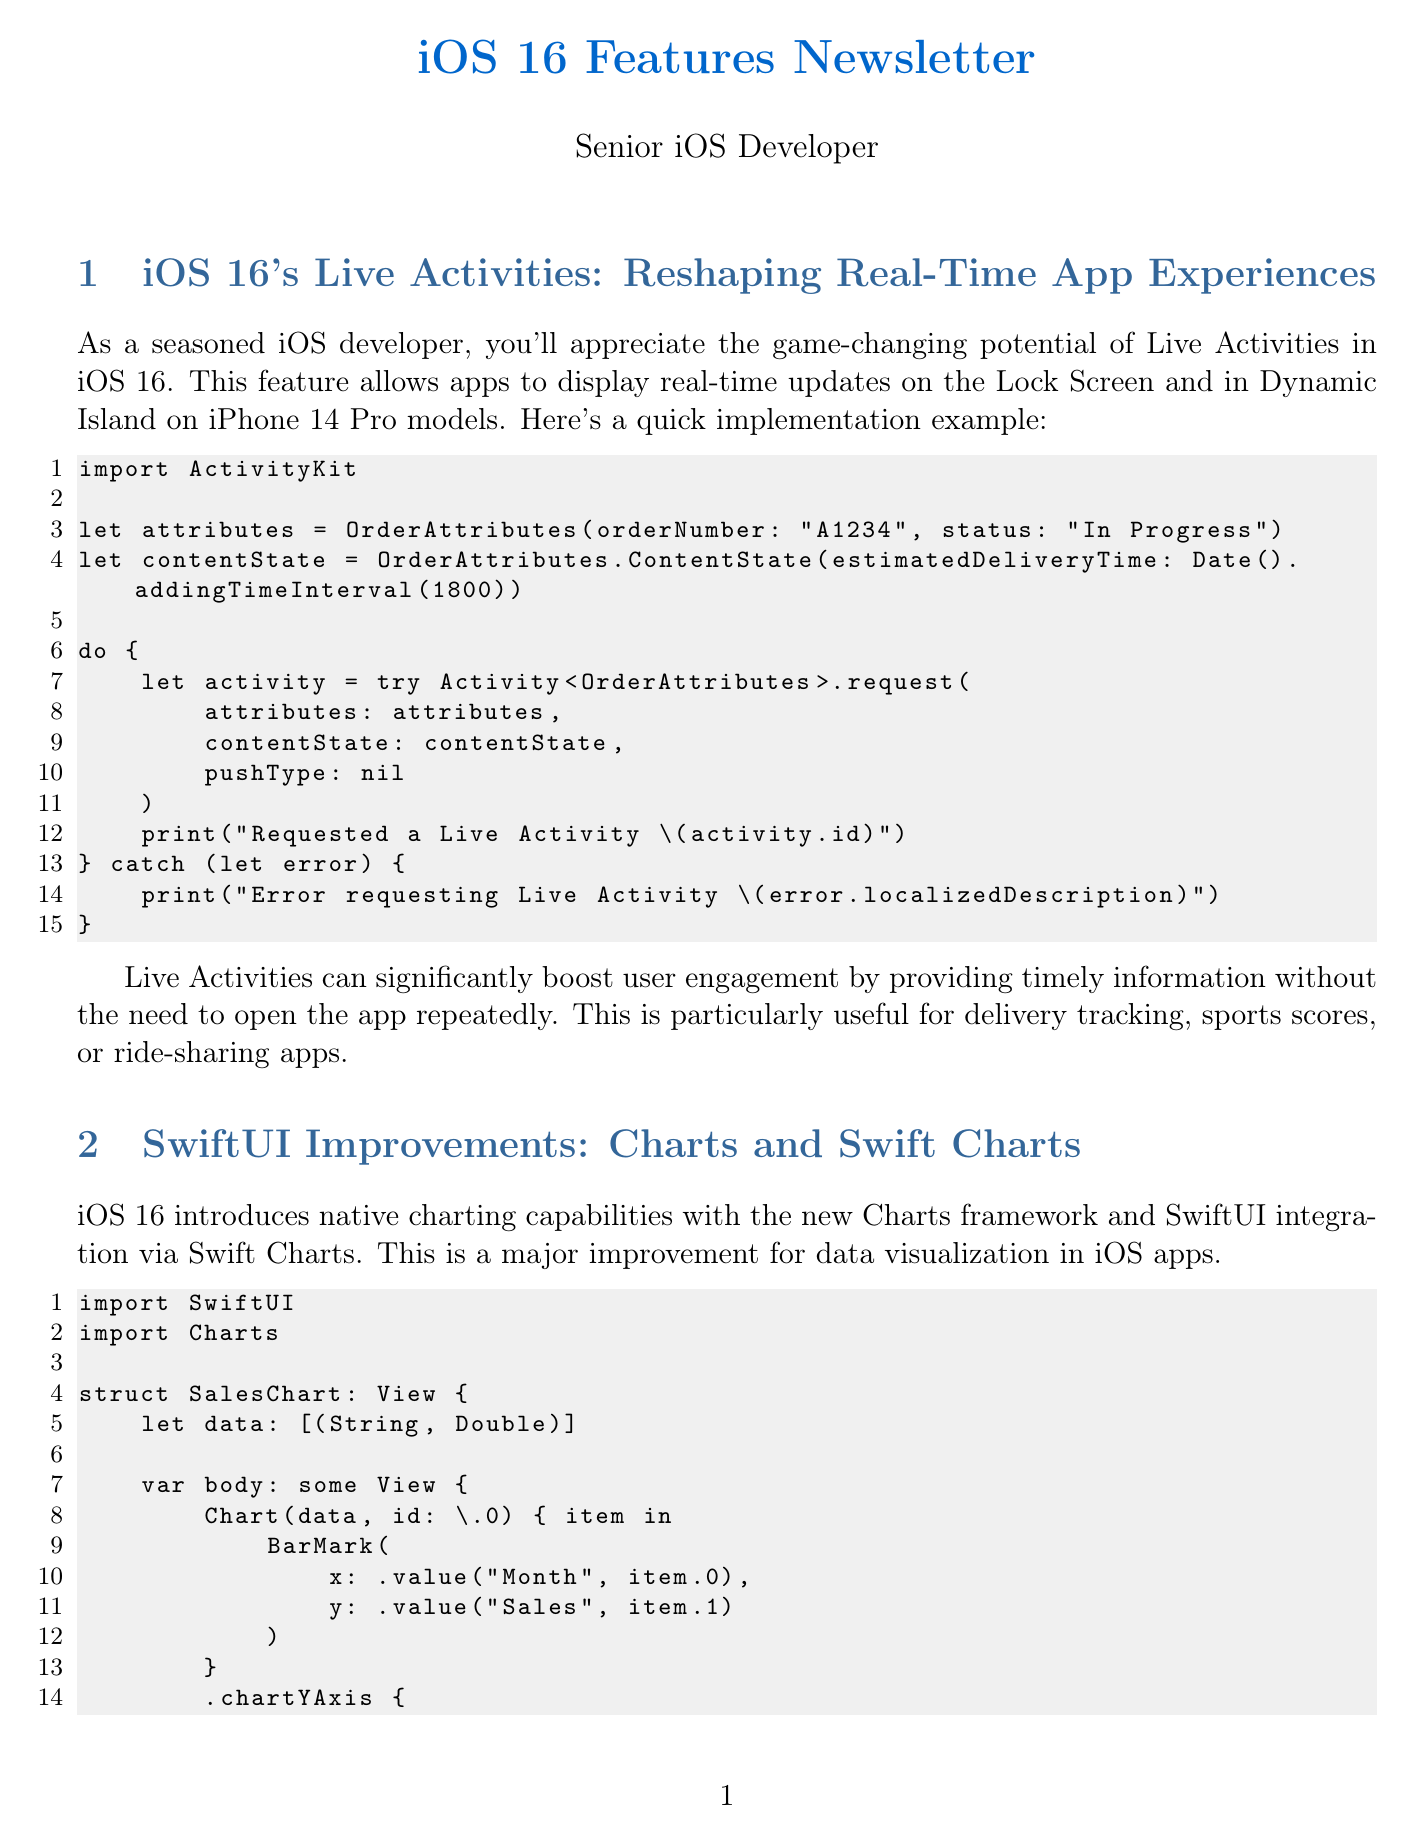what feature allows real-time updates on the Lock Screen? The feature that allows real-time updates on the Lock Screen is called Live Activities.
Answer: Live Activities what is the impact of Live Activities on app engagement? Live Activities can significantly boost user engagement by providing timely information without the need to open the app repeatedly.
Answer: Boost user engagement what framework introduces native charting capabilities in iOS 16? The framework that introduces native charting capabilities is called Charts.
Answer: Charts what was the benchmark improvement in frame rates with Metal 3? The benchmark improvement in frame rates with Metal 3 was 30%.
Answer: 30% how does Focus Filters affect user experience? Focus Filters improve user experience by providing relevant content based on the user's current context.
Answer: Relevant content what privacy feature requires user permission to access the clipboard? The privacy feature that requires user permission to access the clipboard is Paste Permission.
Answer: Paste Permission what is the purpose of SwiftUI previews in iOS 16? SwiftUI previews in iOS 16 support async/await for smoother development workflows.
Answer: Smoother development workflows how much were SwiftUI preview compilation times reduced for large projects? SwiftUI preview compilation times were reduced by up to 50%.
Answer: 50% which permission must be granted for specific Photo Library access? The permission that must be granted for specific Photo Library access is more granular Photo Library access.
Answer: Granular Photo Library access 